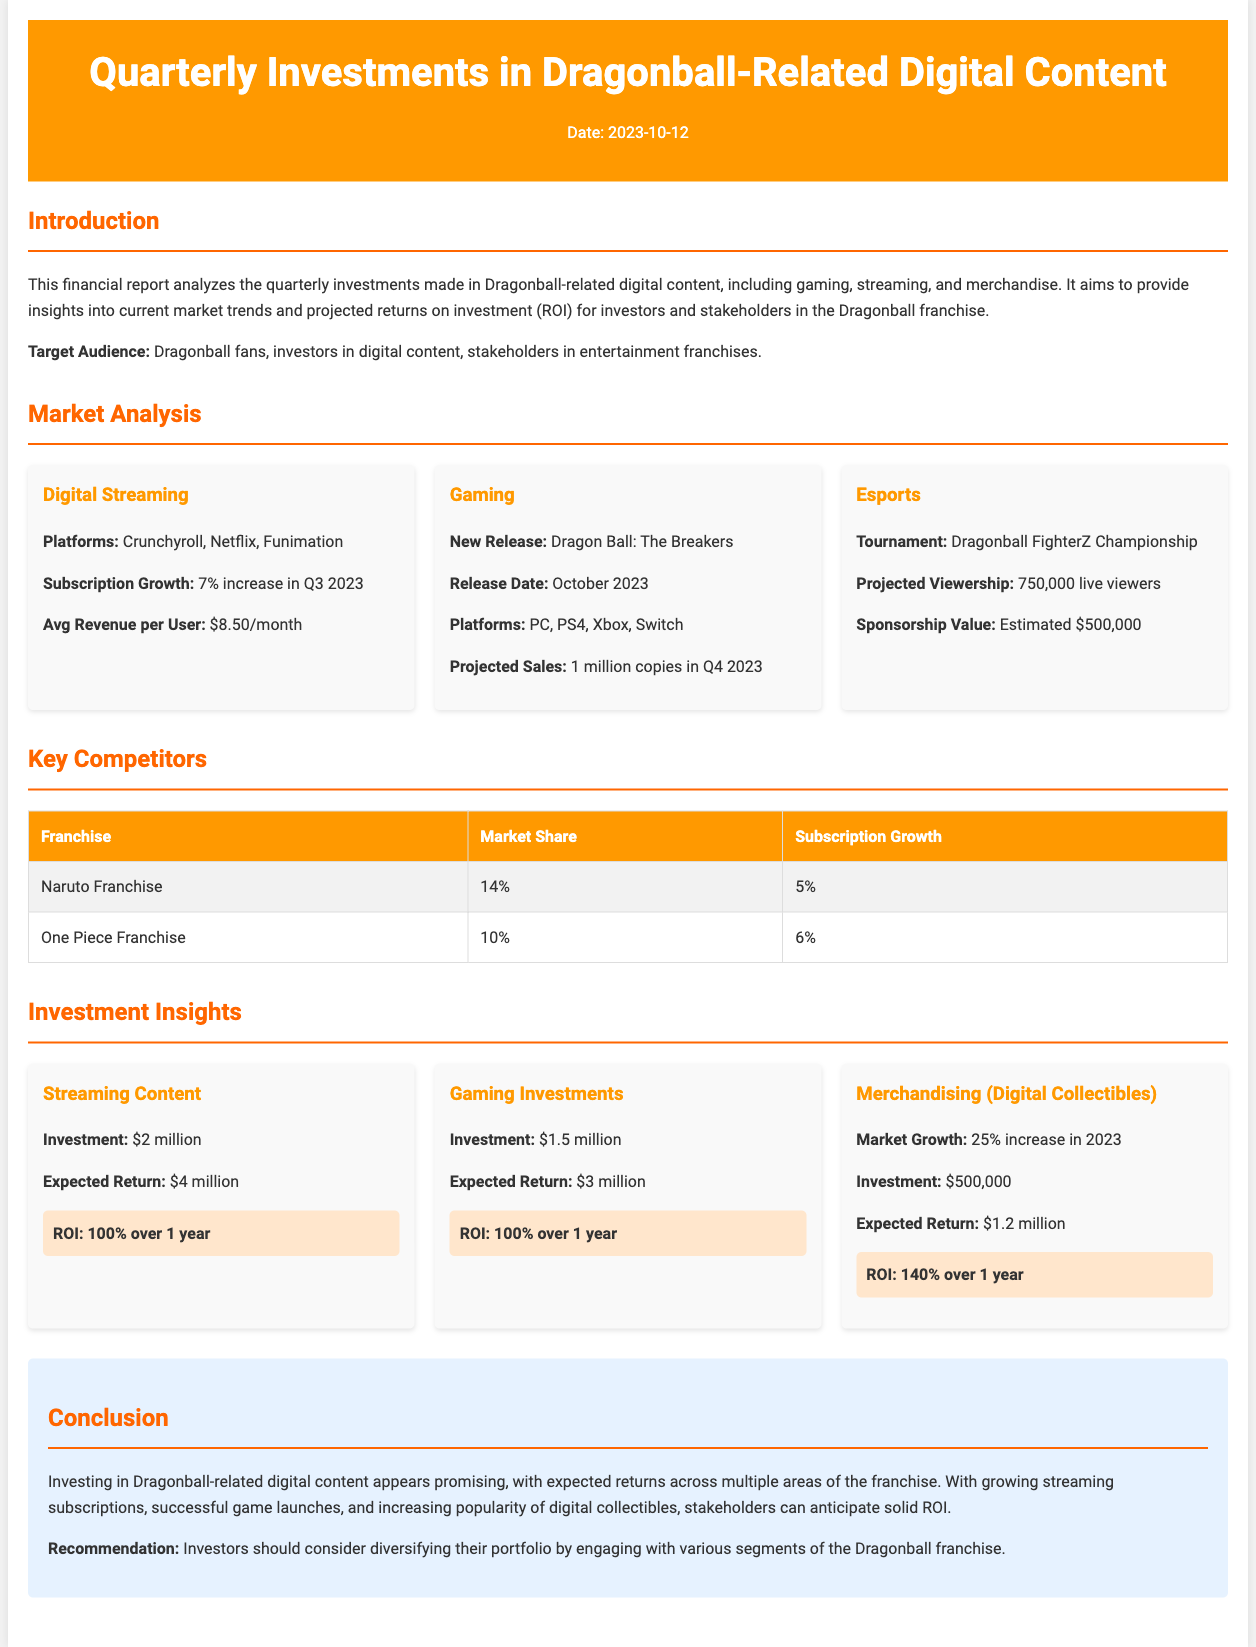What is the date of the report? The report date is mentioned in the header section, which states "Date: 2023-10-12."
Answer: 2023-10-12 What is the subscription growth percentage for digital streaming? The document states that the subscription growth for digital streaming is a "7% increase in Q3 2023."
Answer: 7% What is the expected return on the investment for streaming content? The expected return is provided in the investment insights section for streaming content, listed as "$4 million."
Answer: $4 million What is the projected sales figure for Dragon Ball: The Breakers? The projections for sales of Dragon Ball: The Breakers in Q4 2023 are mentioned as "1 million copies."
Answer: 1 million copies Which franchise holds a market share of 14%? The document lists competitors and states that the "Naruto Franchise" has a market share of "14%."
Answer: Naruto Franchise What is the estimated sponsorship value for the Dragonball FighterZ Championship? The sponsorship value is noted to be "Estimated $500,000" in the esports section.
Answer: Estimated $500,000 What is the investment amount for merchandising (digital collectibles)? The investment amount for merchandising is given as "$500,000" in the investment insights.
Answer: $500,000 What is the ROI for merchandising over one year? The document highlights the ROI for merchandising (digital collectibles) as "140% over 1 year."
Answer: 140% What is the primary recommendation for investors? The conclusion section provides a recommendation for investors to "consider diversifying their portfolio."
Answer: diversify their portfolio 